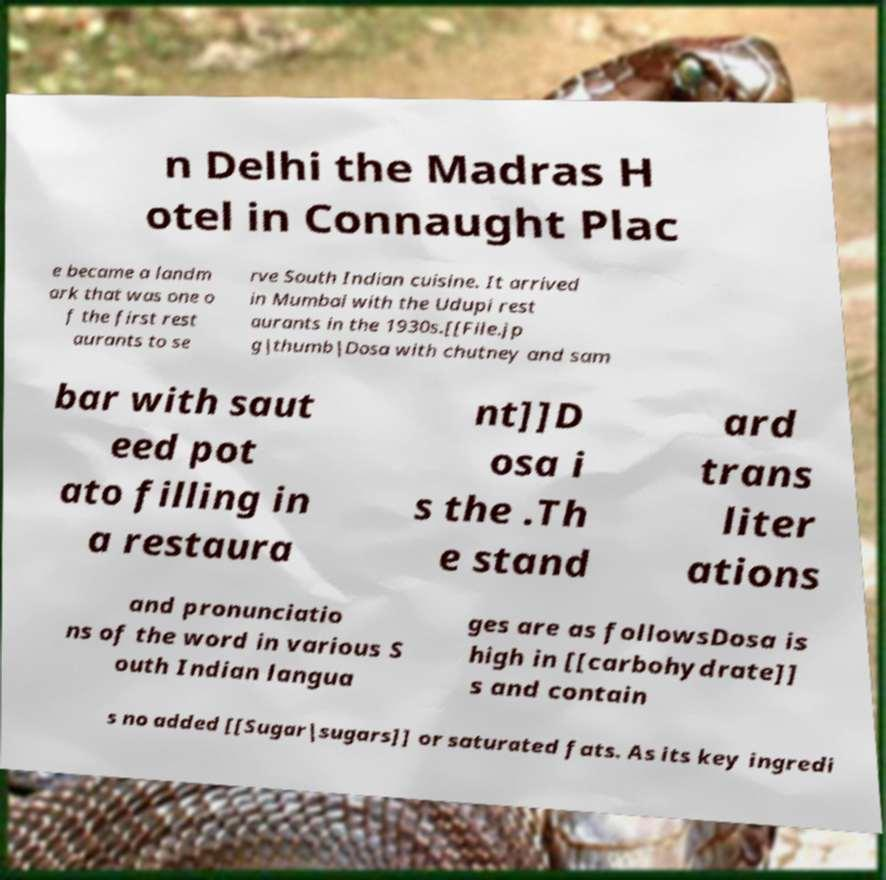There's text embedded in this image that I need extracted. Can you transcribe it verbatim? n Delhi the Madras H otel in Connaught Plac e became a landm ark that was one o f the first rest aurants to se rve South Indian cuisine. It arrived in Mumbai with the Udupi rest aurants in the 1930s.[[File.jp g|thumb|Dosa with chutney and sam bar with saut eed pot ato filling in a restaura nt]]D osa i s the .Th e stand ard trans liter ations and pronunciatio ns of the word in various S outh Indian langua ges are as followsDosa is high in [[carbohydrate]] s and contain s no added [[Sugar|sugars]] or saturated fats. As its key ingredi 